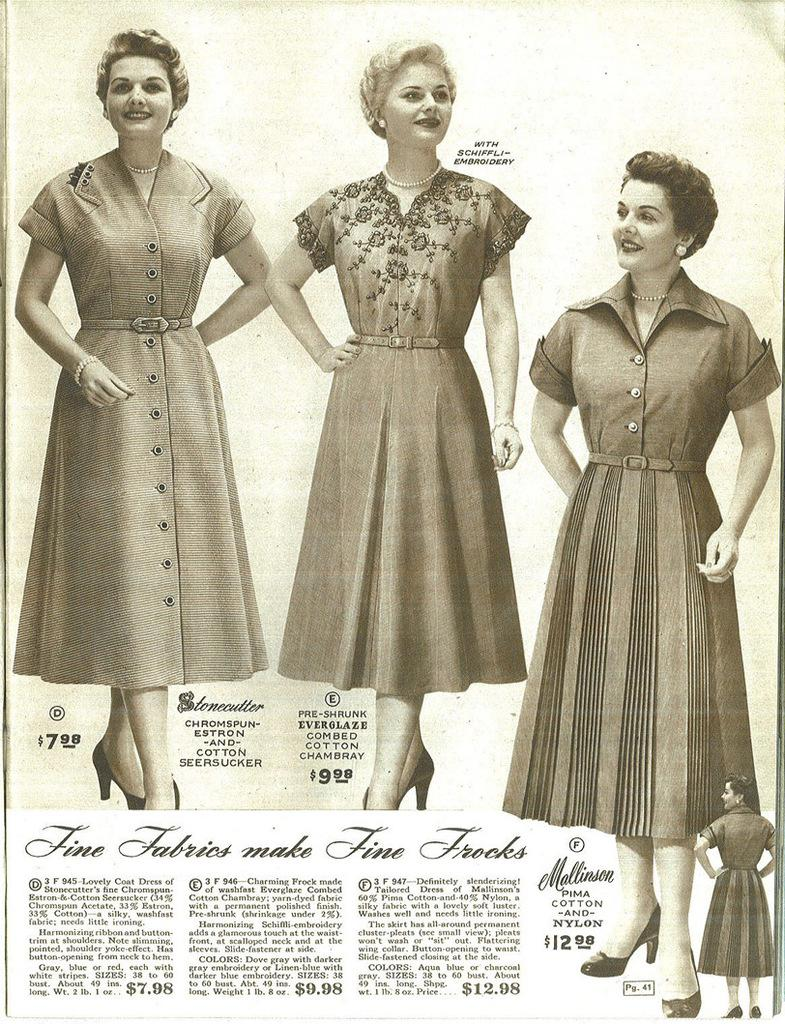What is the main object in the image? There is a paper in the image. What can be seen on the paper? There are pictures of ladies printed on the paper. Is there any text on the paper? Yes, there is text on the paper. Where is the volcano located in the image? There is no volcano present in the image. What type of cart is being used by the ladies in the image? There is no cart present in the image; it only features pictures of ladies on a paper. 